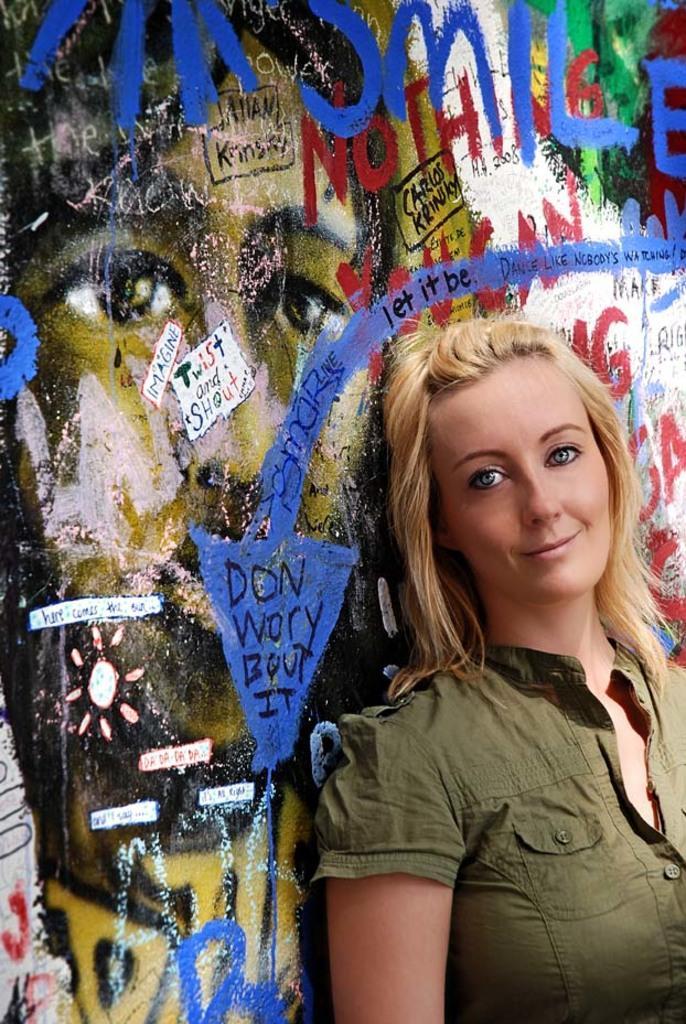Please provide a concise description of this image. In this image we can see a woman and she is smiling. In the background we can see painting and something is written on the wall. 